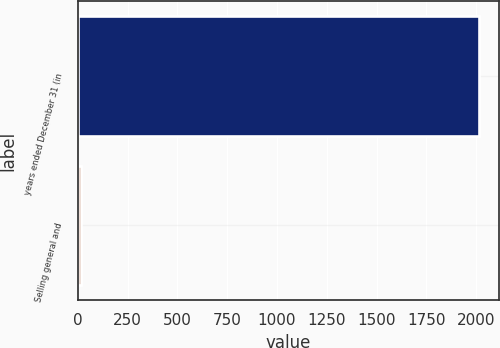<chart> <loc_0><loc_0><loc_500><loc_500><bar_chart><fcel>years ended December 31 (in<fcel>Selling general and<nl><fcel>2012<fcel>15<nl></chart> 